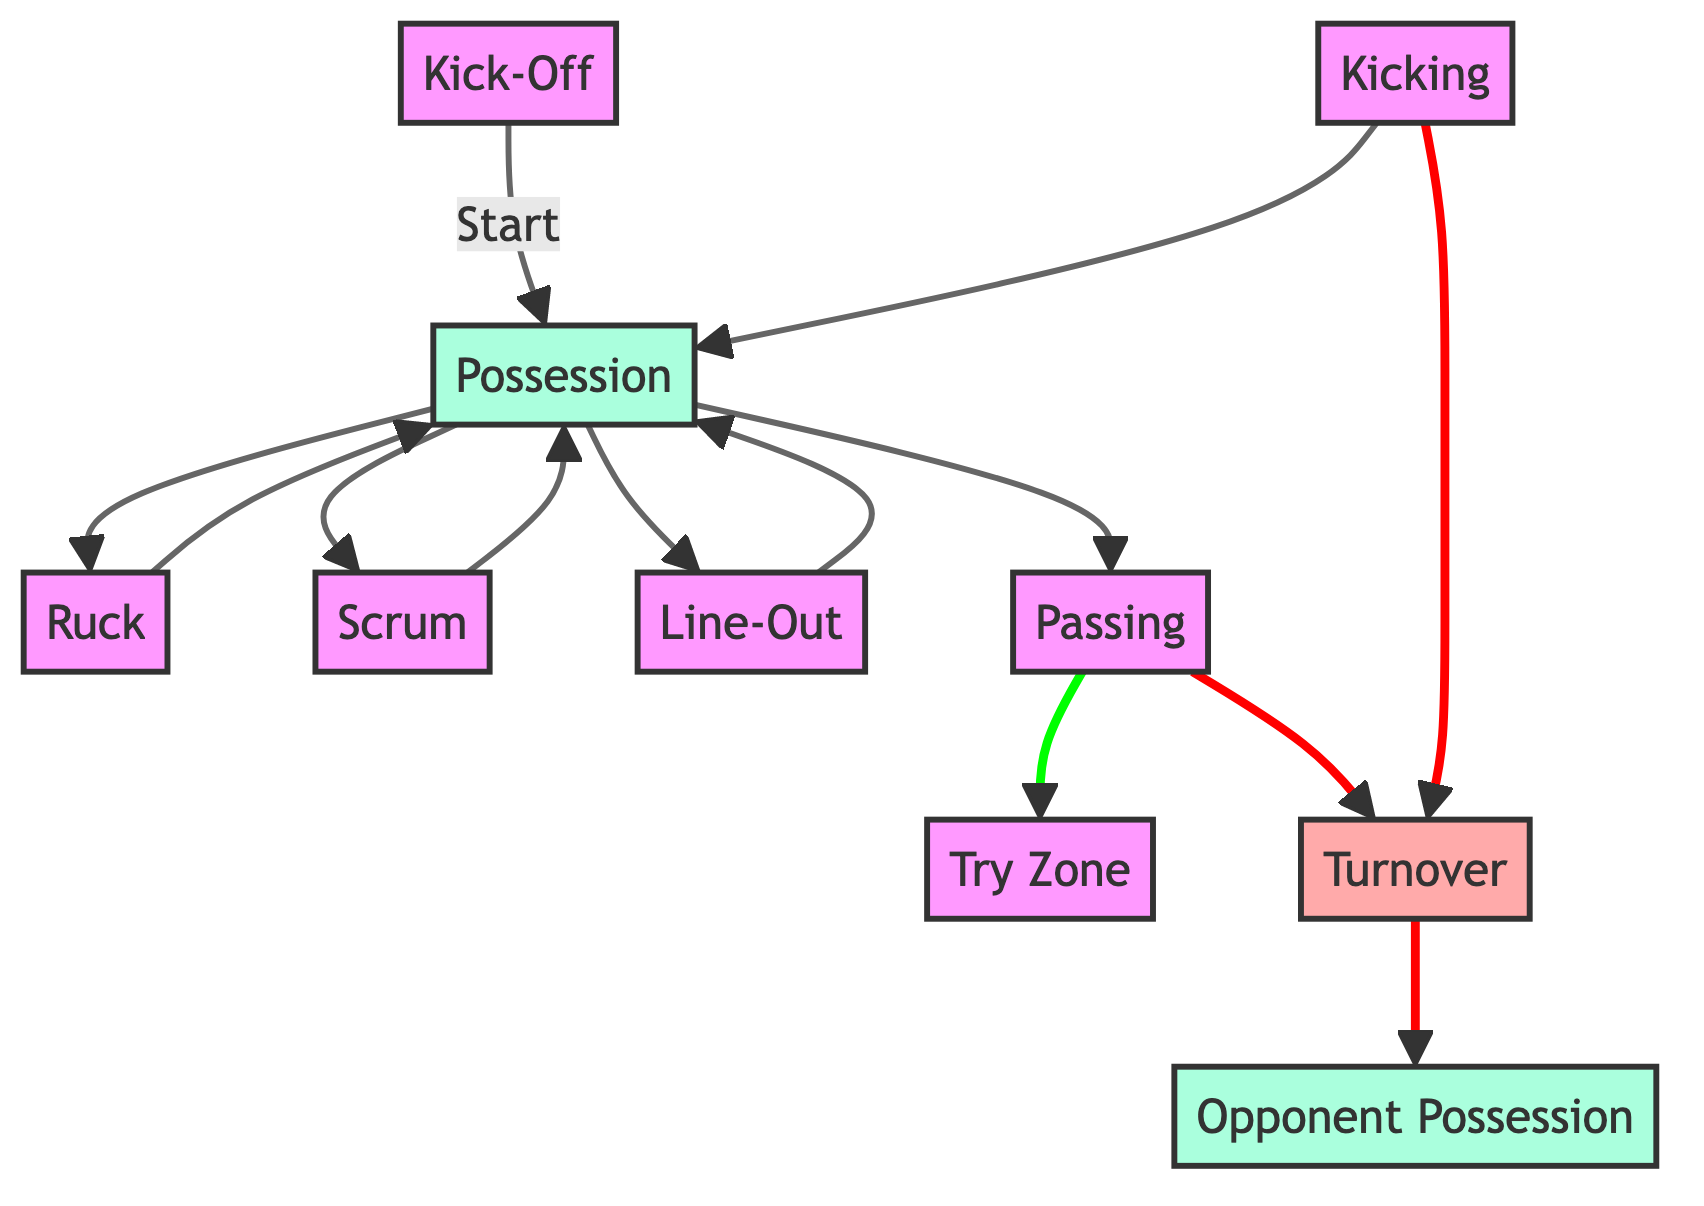What node follows the Kick-Off? The diagram shows an arrow leading from the Kick-Off node to the Possession node, indicating that Possession follows after Kick-Off.
Answer: Possession How many edges are originating from the Possession node? Observing the diagram, there are four edges that originate from the Possession node, each leading to Ruck, Scrum, Line-Out, and Passing.
Answer: 4 What is the outcome of the Passing node? The Passing node has two outgoing edges: one leads to the Try Zone and the other to the Turnover. This indicates that the outcomes of the Passing node can be either reaching the Try Zone or resulting in a Turnover.
Answer: Try Zone and Turnover Which node leads to Opponent Possession? The diagram shows that the Turnover node has an arrow leading to the Opponent Possession node, indicating that a Turnover results in Opponent Possession.
Answer: Turnover What type of nodes can lead to Possession? The diagram shows three types of nodes leading to Possession: Ruck, Scrum, and Line-Out. Additionally, Kicking also leads to Possession, making four types in total.
Answer: Ruck, Scrum, Line-Out, Kicking How many total nodes are present in this diagram? By counting the nodes listed in the diagram, we find a total of ten nodes, which include Kick-Off, Possession, Ruck, Scrum, Line-Out, Passing, Try Zone, Turnover, Opponent Possession, and Kicking.
Answer: 10 In what scenario might the team lose possession? The diagram indicates that the team can lose possession when a Turnover occurs, as this event is represented in the graph with an outgoing edge to Opponent Possession.
Answer: Turnover What is the relationship between Kicking and Possession? In the diagram, there is a direct connection from the Kicking node to the Possession node, indicating that Kicking can lead to Possession.
Answer: Kicking leads to Possession 